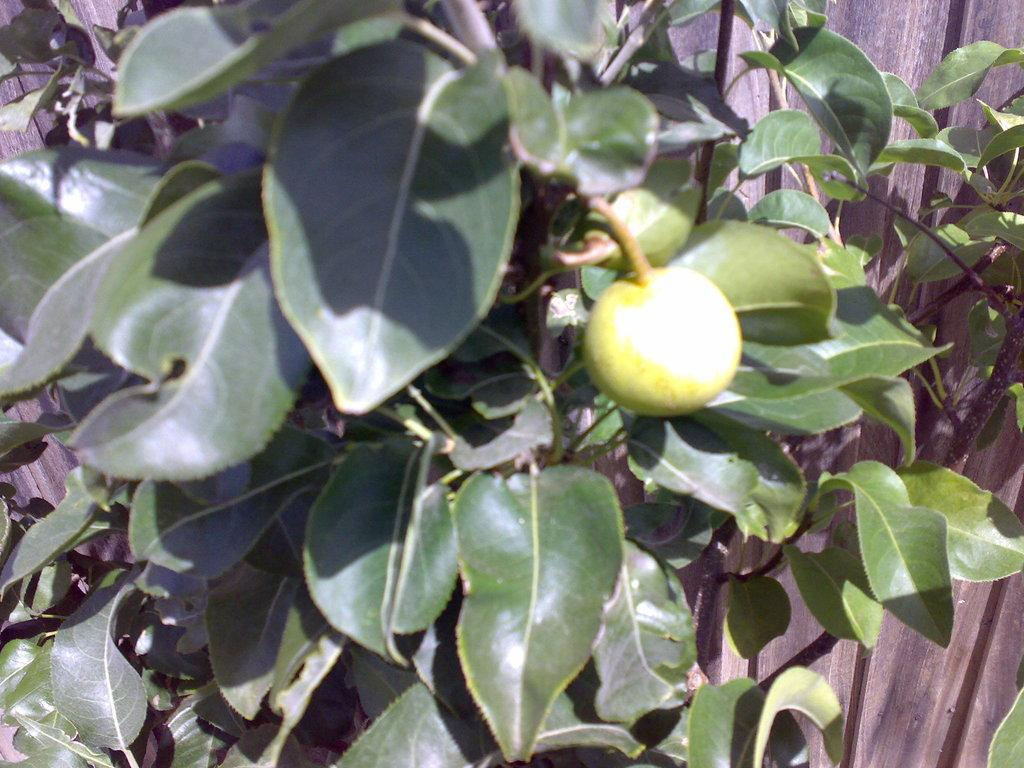What type of plant is visible in the image? There is a plant with fruit in the image. What can be seen in the background of the image? There is a wooden wall in the background of the image. How many spiders are crawling on the fruit in the image? There are no spiders visible in the image; it only features a plant with fruit. What type of ray can be seen swimming in the background of the image? There is no ray present in the image; it only features a plant with fruit and a wooden wall in the background. 